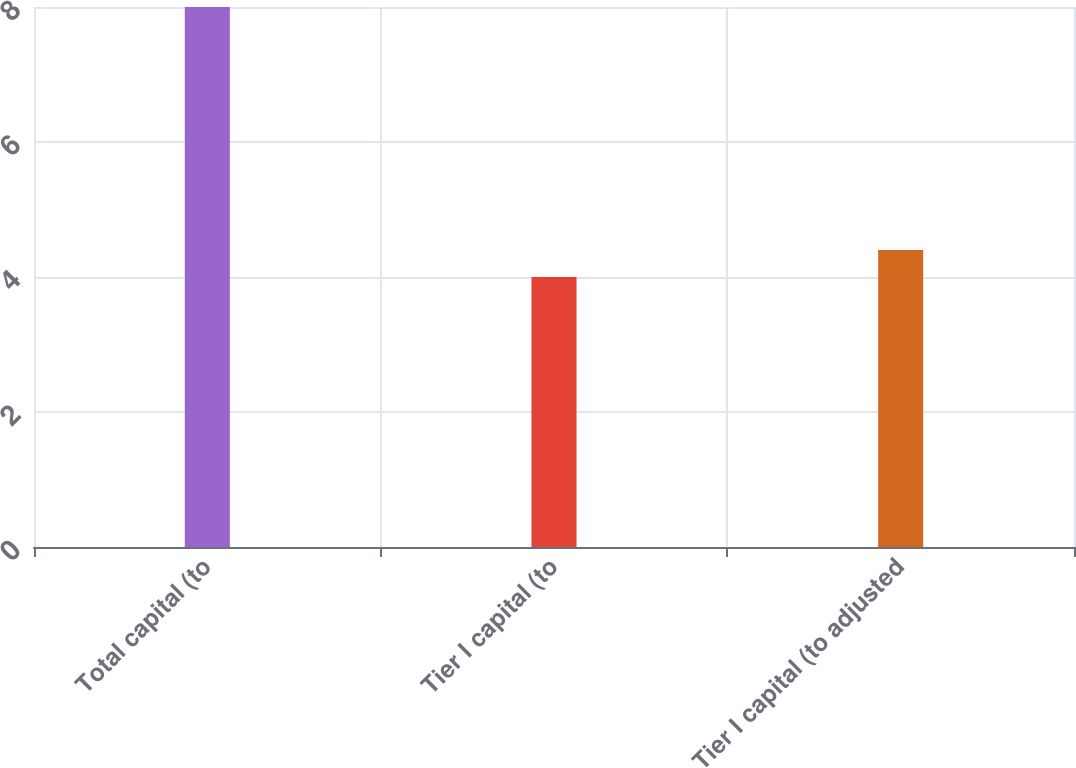Convert chart to OTSL. <chart><loc_0><loc_0><loc_500><loc_500><bar_chart><fcel>Total capital (to<fcel>Tier I capital (to<fcel>Tier I capital (to adjusted<nl><fcel>8<fcel>4<fcel>4.4<nl></chart> 